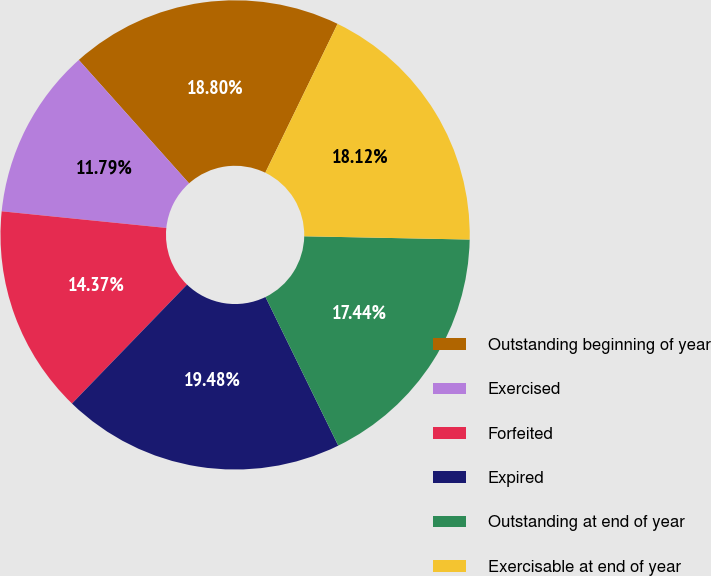<chart> <loc_0><loc_0><loc_500><loc_500><pie_chart><fcel>Outstanding beginning of year<fcel>Exercised<fcel>Forfeited<fcel>Expired<fcel>Outstanding at end of year<fcel>Exercisable at end of year<nl><fcel>18.8%<fcel>11.79%<fcel>14.37%<fcel>19.48%<fcel>17.44%<fcel>18.12%<nl></chart> 